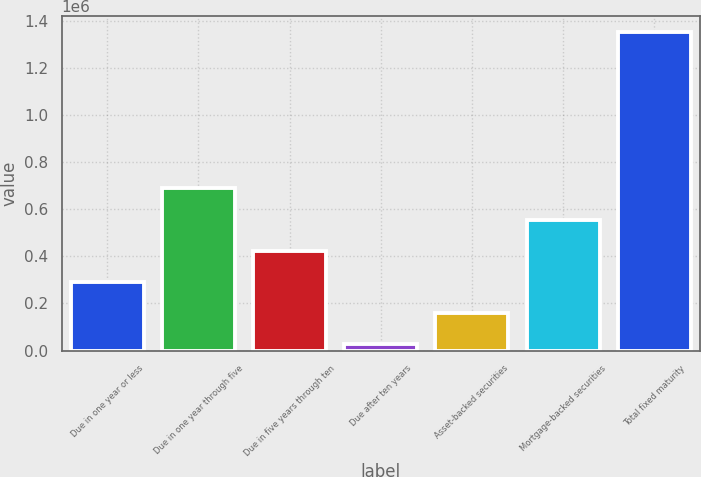Convert chart to OTSL. <chart><loc_0><loc_0><loc_500><loc_500><bar_chart><fcel>Due in one year or less<fcel>Due in one year through five<fcel>Due in five years through ten<fcel>Due after ten years<fcel>Asset-backed securities<fcel>Mortgage-backed securities<fcel>Total fixed maturity<nl><fcel>290947<fcel>688776<fcel>423556<fcel>25727<fcel>158337<fcel>556166<fcel>1.35182e+06<nl></chart> 